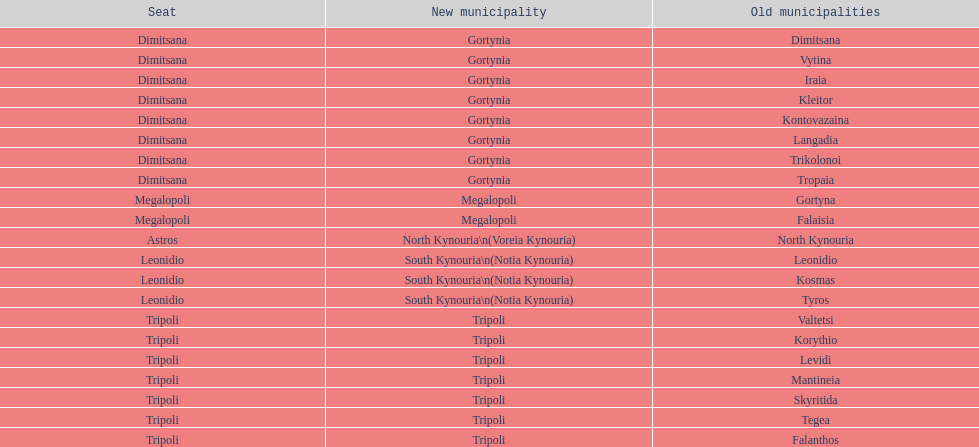How many old municipalities were in tripoli? 8. 